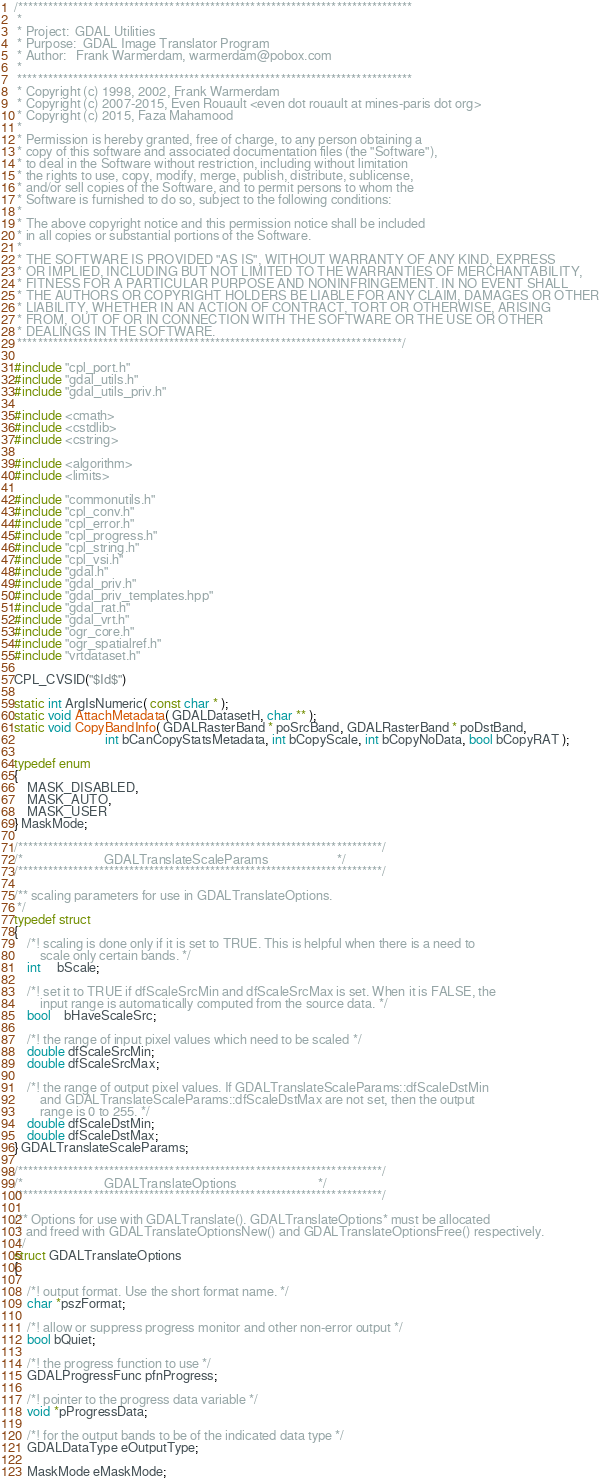Convert code to text. <code><loc_0><loc_0><loc_500><loc_500><_C++_>/******************************************************************************
 *
 * Project:  GDAL Utilities
 * Purpose:  GDAL Image Translator Program
 * Author:   Frank Warmerdam, warmerdam@pobox.com
 *
 ******************************************************************************
 * Copyright (c) 1998, 2002, Frank Warmerdam
 * Copyright (c) 2007-2015, Even Rouault <even dot rouault at mines-paris dot org>
 * Copyright (c) 2015, Faza Mahamood
 *
 * Permission is hereby granted, free of charge, to any person obtaining a
 * copy of this software and associated documentation files (the "Software"),
 * to deal in the Software without restriction, including without limitation
 * the rights to use, copy, modify, merge, publish, distribute, sublicense,
 * and/or sell copies of the Software, and to permit persons to whom the
 * Software is furnished to do so, subject to the following conditions:
 *
 * The above copyright notice and this permission notice shall be included
 * in all copies or substantial portions of the Software.
 *
 * THE SOFTWARE IS PROVIDED "AS IS", WITHOUT WARRANTY OF ANY KIND, EXPRESS
 * OR IMPLIED, INCLUDING BUT NOT LIMITED TO THE WARRANTIES OF MERCHANTABILITY,
 * FITNESS FOR A PARTICULAR PURPOSE AND NONINFRINGEMENT. IN NO EVENT SHALL
 * THE AUTHORS OR COPYRIGHT HOLDERS BE LIABLE FOR ANY CLAIM, DAMAGES OR OTHER
 * LIABILITY, WHETHER IN AN ACTION OF CONTRACT, TORT OR OTHERWISE, ARISING
 * FROM, OUT OF OR IN CONNECTION WITH THE SOFTWARE OR THE USE OR OTHER
 * DEALINGS IN THE SOFTWARE.
 ****************************************************************************/

#include "cpl_port.h"
#include "gdal_utils.h"
#include "gdal_utils_priv.h"

#include <cmath>
#include <cstdlib>
#include <cstring>

#include <algorithm>
#include <limits>

#include "commonutils.h"
#include "cpl_conv.h"
#include "cpl_error.h"
#include "cpl_progress.h"
#include "cpl_string.h"
#include "cpl_vsi.h"
#include "gdal.h"
#include "gdal_priv.h"
#include "gdal_priv_templates.hpp"
#include "gdal_rat.h"
#include "gdal_vrt.h"
#include "ogr_core.h"
#include "ogr_spatialref.h"
#include "vrtdataset.h"

CPL_CVSID("$Id$")

static int ArgIsNumeric( const char * );
static void AttachMetadata( GDALDatasetH, char ** );
static void CopyBandInfo( GDALRasterBand * poSrcBand, GDALRasterBand * poDstBand,
                            int bCanCopyStatsMetadata, int bCopyScale, int bCopyNoData, bool bCopyRAT );

typedef enum
{
    MASK_DISABLED,
    MASK_AUTO,
    MASK_USER
} MaskMode;

/************************************************************************/
/*                         GDALTranslateScaleParams                     */
/************************************************************************/

/** scaling parameters for use in GDALTranslateOptions.
 */
typedef struct
{
    /*! scaling is done only if it is set to TRUE. This is helpful when there is a need to
        scale only certain bands. */
    int     bScale;

    /*! set it to TRUE if dfScaleSrcMin and dfScaleSrcMax is set. When it is FALSE, the
        input range is automatically computed from the source data. */
    bool    bHaveScaleSrc;

    /*! the range of input pixel values which need to be scaled */
    double dfScaleSrcMin;
    double dfScaleSrcMax;

    /*! the range of output pixel values. If GDALTranslateScaleParams::dfScaleDstMin
        and GDALTranslateScaleParams::dfScaleDstMax are not set, then the output
        range is 0 to 255. */
    double dfScaleDstMin;
    double dfScaleDstMax;
} GDALTranslateScaleParams;

/************************************************************************/
/*                         GDALTranslateOptions                         */
/************************************************************************/

/** Options for use with GDALTranslate(). GDALTranslateOptions* must be allocated
 * and freed with GDALTranslateOptionsNew() and GDALTranslateOptionsFree() respectively.
 */
struct GDALTranslateOptions
{

    /*! output format. Use the short format name. */
    char *pszFormat;

    /*! allow or suppress progress monitor and other non-error output */
    bool bQuiet;

    /*! the progress function to use */
    GDALProgressFunc pfnProgress;

    /*! pointer to the progress data variable */
    void *pProgressData;

    /*! for the output bands to be of the indicated data type */
    GDALDataType eOutputType;

    MaskMode eMaskMode;
</code> 